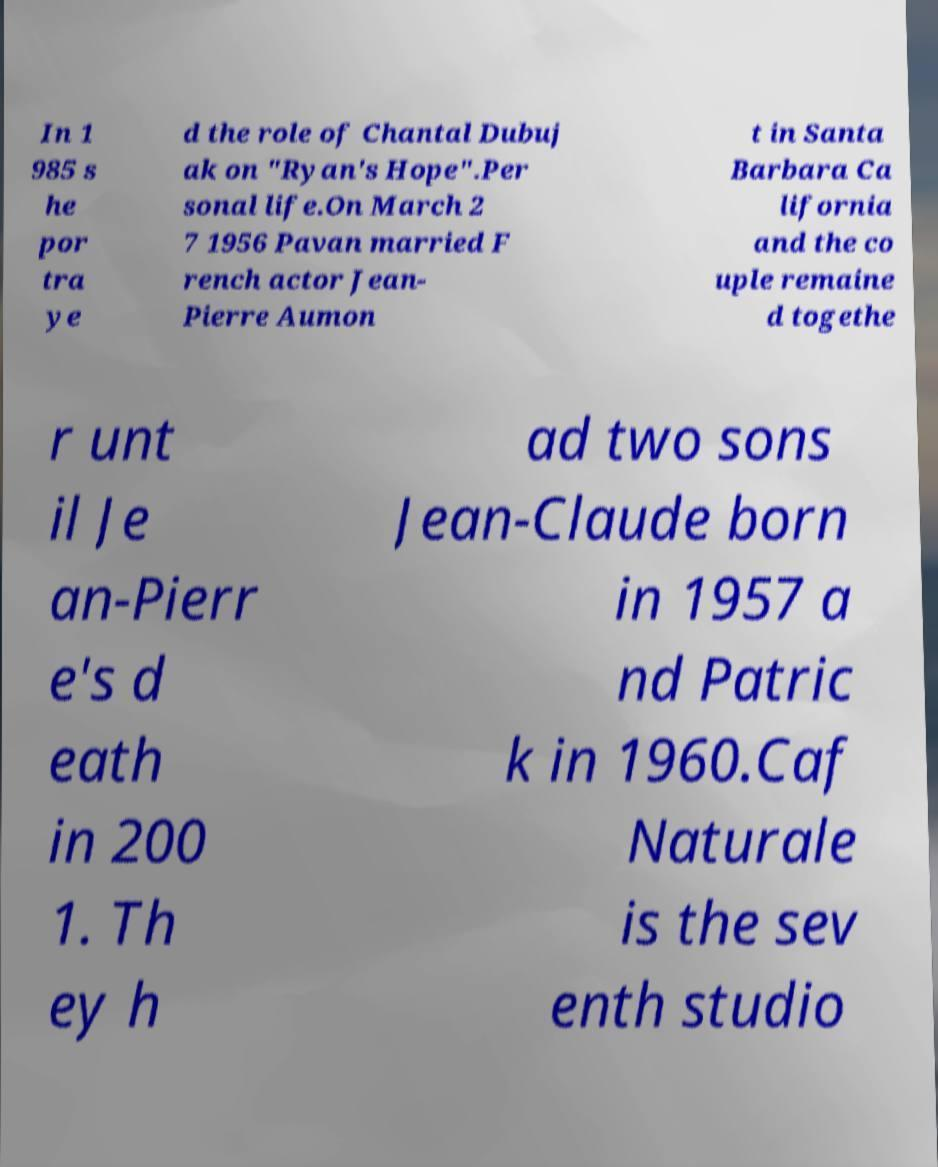Can you accurately transcribe the text from the provided image for me? In 1 985 s he por tra ye d the role of Chantal Dubuj ak on "Ryan's Hope".Per sonal life.On March 2 7 1956 Pavan married F rench actor Jean- Pierre Aumon t in Santa Barbara Ca lifornia and the co uple remaine d togethe r unt il Je an-Pierr e's d eath in 200 1. Th ey h ad two sons Jean-Claude born in 1957 a nd Patric k in 1960.Caf Naturale is the sev enth studio 